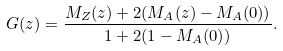<formula> <loc_0><loc_0><loc_500><loc_500>G ( z ) = \frac { M _ { Z } ( z ) + 2 ( M _ { A } ( z ) - M _ { A } ( 0 ) ) } { 1 + 2 ( 1 - M _ { A } ( 0 ) ) } .</formula> 